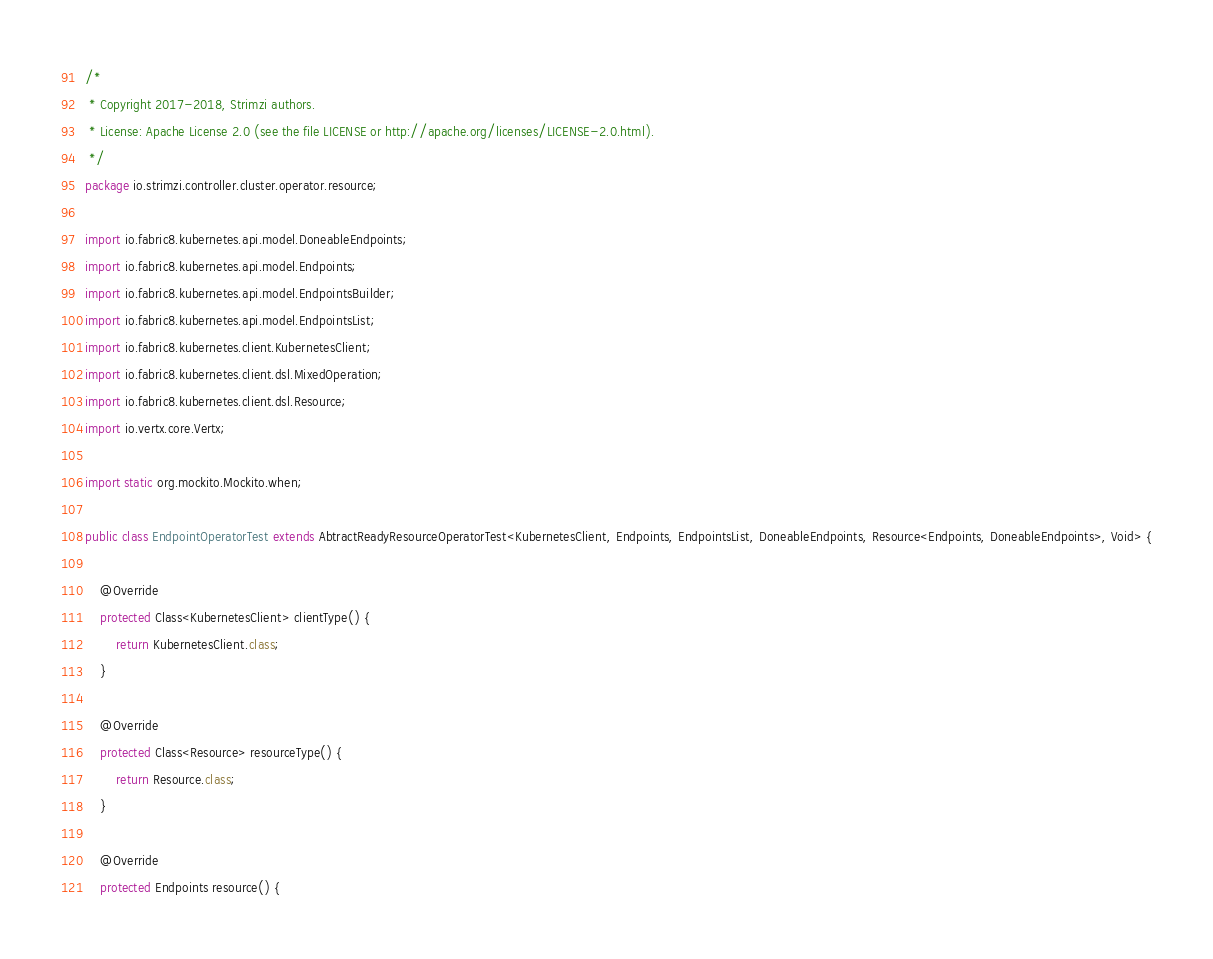Convert code to text. <code><loc_0><loc_0><loc_500><loc_500><_Java_>/*
 * Copyright 2017-2018, Strimzi authors.
 * License: Apache License 2.0 (see the file LICENSE or http://apache.org/licenses/LICENSE-2.0.html).
 */
package io.strimzi.controller.cluster.operator.resource;

import io.fabric8.kubernetes.api.model.DoneableEndpoints;
import io.fabric8.kubernetes.api.model.Endpoints;
import io.fabric8.kubernetes.api.model.EndpointsBuilder;
import io.fabric8.kubernetes.api.model.EndpointsList;
import io.fabric8.kubernetes.client.KubernetesClient;
import io.fabric8.kubernetes.client.dsl.MixedOperation;
import io.fabric8.kubernetes.client.dsl.Resource;
import io.vertx.core.Vertx;

import static org.mockito.Mockito.when;

public class EndpointOperatorTest extends AbtractReadyResourceOperatorTest<KubernetesClient, Endpoints, EndpointsList, DoneableEndpoints, Resource<Endpoints, DoneableEndpoints>, Void> {

    @Override
    protected Class<KubernetesClient> clientType() {
        return KubernetesClient.class;
    }

    @Override
    protected Class<Resource> resourceType() {
        return Resource.class;
    }

    @Override
    protected Endpoints resource() {</code> 